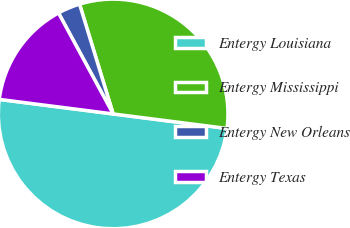<chart> <loc_0><loc_0><loc_500><loc_500><pie_chart><fcel>Entergy Louisiana<fcel>Entergy Mississippi<fcel>Entergy New Orleans<fcel>Entergy Texas<nl><fcel>50.0%<fcel>31.75%<fcel>3.17%<fcel>15.08%<nl></chart> 